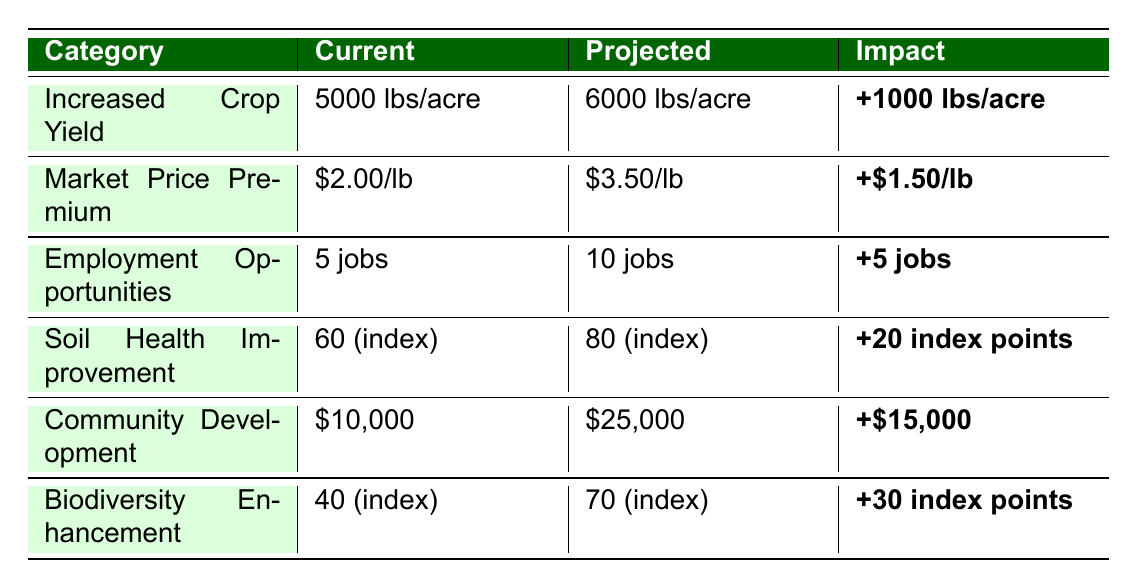What is the projected increase in crop yield per acre? According to the table, the current yield is 5000 lbs/acre and the projected yield is 6000 lbs/acre. The difference between them is 6000 - 5000 = 1000 lbs/acre.
Answer: 1000 lbs/acre What is the current market price for organic produce? The table shows that the current market price is $2.00/lb.
Answer: $2.00/lb How many additional jobs are projected to be created by organic farming? The current number of jobs is 5, and the projected number of jobs is 10. The increase is calculated as 10 - 5 = 5 jobs.
Answer: 5 jobs What is the projected local investment increase from organic farming? The current local investment is $10,000, while the projected investment is $25,000. The increase is $25,000 - $10,000 = $15,000.
Answer: $15,000 Is the projected soil health index higher or lower than the current index? The current soil quality index is 60, and the projected index is 80. Since 80 is greater than 60, the projected index is higher.
Answer: Higher What is the difference in biodiversity index before and after switching to organic farming? The current biodiversity index is 40 and the projected index is 70. The difference is 70 - 40 = 30 index points.
Answer: 30 index points How much more can farmers expect to earn per pound of produce compared to current prices? The current market price is $2.00/lb and the projected market price is $3.50/lb. The difference is $3.50 - $2.00 = $1.50/lb.
Answer: $1.50/lb What is the average projected yield per acre and the average employment increase? The projected yield per acre is 6000 lbs, and the projected number of jobs is 10. The average of these two values is (6000 + 10) / 2 = 3005.
Answer: 3005 If a farmer has 5 acres, how much total yield increase can they expect? The yield increase is 1000 lbs/acre. For 5 acres, the total increase would be 1000 lbs/acre * 5 acres = 5000 lbs.
Answer: 5000 lbs How much will the local investment increase percentage-wise? The current investment is $10,000 and the projected investment is $25,000. The increase is $15,000, and the percentage increase is ($15,000 / $10,000) * 100% = 150%.
Answer: 150% 